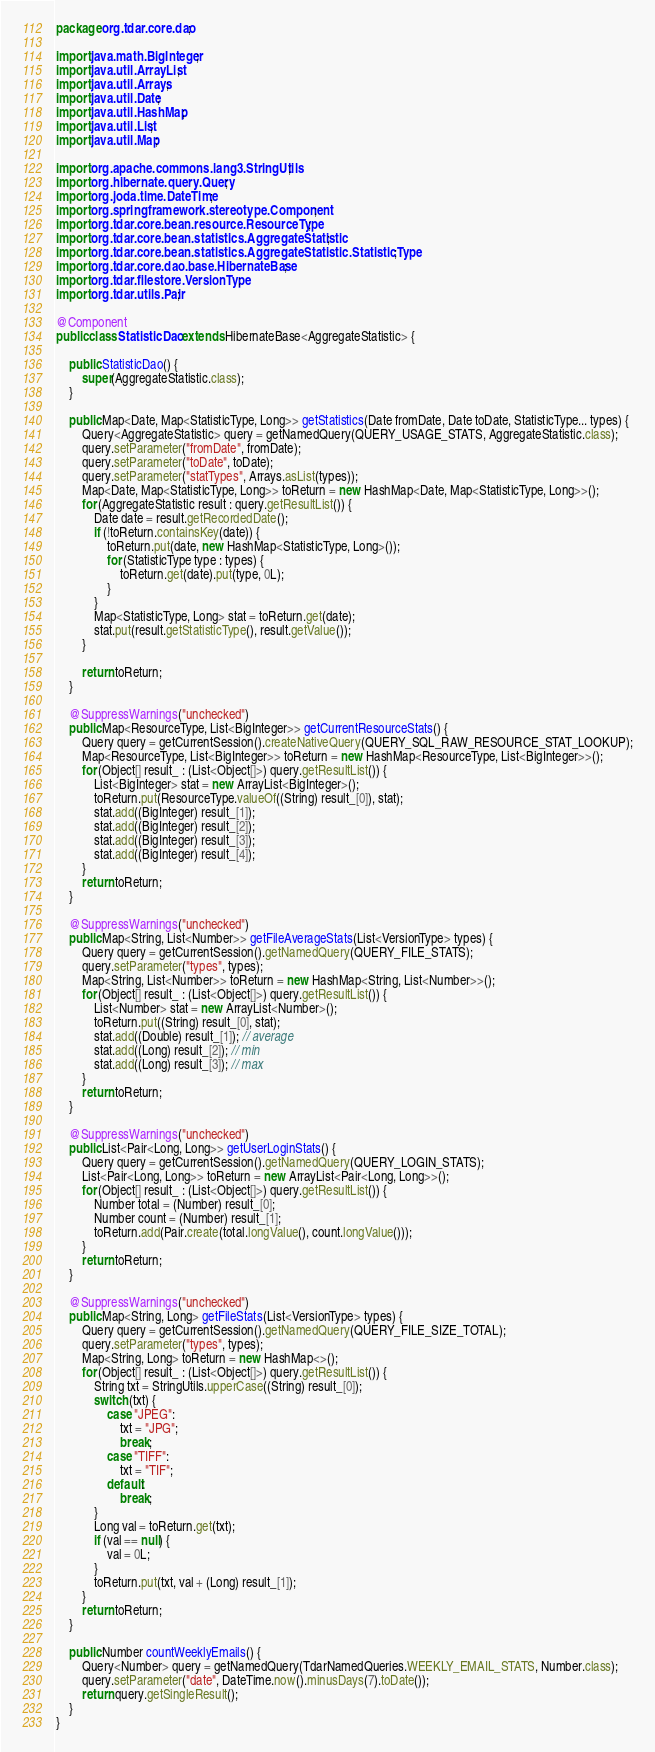<code> <loc_0><loc_0><loc_500><loc_500><_Java_>package org.tdar.core.dao;

import java.math.BigInteger;
import java.util.ArrayList;
import java.util.Arrays;
import java.util.Date;
import java.util.HashMap;
import java.util.List;
import java.util.Map;

import org.apache.commons.lang3.StringUtils;
import org.hibernate.query.Query;
import org.joda.time.DateTime;
import org.springframework.stereotype.Component;
import org.tdar.core.bean.resource.ResourceType;
import org.tdar.core.bean.statistics.AggregateStatistic;
import org.tdar.core.bean.statistics.AggregateStatistic.StatisticType;
import org.tdar.core.dao.base.HibernateBase;
import org.tdar.filestore.VersionType;
import org.tdar.utils.Pair;

@Component
public class StatisticDao extends HibernateBase<AggregateStatistic> {

    public StatisticDao() {
        super(AggregateStatistic.class);
    }

    public Map<Date, Map<StatisticType, Long>> getStatistics(Date fromDate, Date toDate, StatisticType... types) {
        Query<AggregateStatistic> query = getNamedQuery(QUERY_USAGE_STATS, AggregateStatistic.class);
        query.setParameter("fromDate", fromDate);
        query.setParameter("toDate", toDate);
        query.setParameter("statTypes", Arrays.asList(types));
        Map<Date, Map<StatisticType, Long>> toReturn = new HashMap<Date, Map<StatisticType, Long>>();
        for (AggregateStatistic result : query.getResultList()) {
            Date date = result.getRecordedDate();
            if (!toReturn.containsKey(date)) {
                toReturn.put(date, new HashMap<StatisticType, Long>());
                for (StatisticType type : types) {
                    toReturn.get(date).put(type, 0L);
                }
            }
            Map<StatisticType, Long> stat = toReturn.get(date);
            stat.put(result.getStatisticType(), result.getValue());
        }

        return toReturn;
    }

    @SuppressWarnings("unchecked")
    public Map<ResourceType, List<BigInteger>> getCurrentResourceStats() {
        Query query = getCurrentSession().createNativeQuery(QUERY_SQL_RAW_RESOURCE_STAT_LOOKUP);
        Map<ResourceType, List<BigInteger>> toReturn = new HashMap<ResourceType, List<BigInteger>>();
        for (Object[] result_ : (List<Object[]>) query.getResultList()) {
            List<BigInteger> stat = new ArrayList<BigInteger>();
            toReturn.put(ResourceType.valueOf((String) result_[0]), stat);
            stat.add((BigInteger) result_[1]);
            stat.add((BigInteger) result_[2]);
            stat.add((BigInteger) result_[3]);
            stat.add((BigInteger) result_[4]);
        }
        return toReturn;
    }

    @SuppressWarnings("unchecked")
    public Map<String, List<Number>> getFileAverageStats(List<VersionType> types) {
        Query query = getCurrentSession().getNamedQuery(QUERY_FILE_STATS);
        query.setParameter("types", types);
        Map<String, List<Number>> toReturn = new HashMap<String, List<Number>>();
        for (Object[] result_ : (List<Object[]>) query.getResultList()) {
            List<Number> stat = new ArrayList<Number>();
            toReturn.put((String) result_[0], stat);
            stat.add((Double) result_[1]); // average
            stat.add((Long) result_[2]); // min
            stat.add((Long) result_[3]); // max
        }
        return toReturn;
    }

    @SuppressWarnings("unchecked")
    public List<Pair<Long, Long>> getUserLoginStats() {
        Query query = getCurrentSession().getNamedQuery(QUERY_LOGIN_STATS);
        List<Pair<Long, Long>> toReturn = new ArrayList<Pair<Long, Long>>();
        for (Object[] result_ : (List<Object[]>) query.getResultList()) {
            Number total = (Number) result_[0];
            Number count = (Number) result_[1];
            toReturn.add(Pair.create(total.longValue(), count.longValue()));
        }
        return toReturn;
    }

    @SuppressWarnings("unchecked")
    public Map<String, Long> getFileStats(List<VersionType> types) {
        Query query = getCurrentSession().getNamedQuery(QUERY_FILE_SIZE_TOTAL);
        query.setParameter("types", types);
        Map<String, Long> toReturn = new HashMap<>();
        for (Object[] result_ : (List<Object[]>) query.getResultList()) {
            String txt = StringUtils.upperCase((String) result_[0]);
            switch (txt) {
                case "JPEG":
                    txt = "JPG";
                    break;
                case "TIFF":
                    txt = "TIF";
                default:
                    break;
            }
            Long val = toReturn.get(txt);
            if (val == null) {
                val = 0L;
            }
            toReturn.put(txt, val + (Long) result_[1]);
        }
        return toReturn;
    }

    public Number countWeeklyEmails() {
        Query<Number> query = getNamedQuery(TdarNamedQueries.WEEKLY_EMAIL_STATS, Number.class);
        query.setParameter("date", DateTime.now().minusDays(7).toDate());
        return query.getSingleResult();
    }
}
</code> 